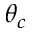Convert formula to latex. <formula><loc_0><loc_0><loc_500><loc_500>\theta _ { c }</formula> 